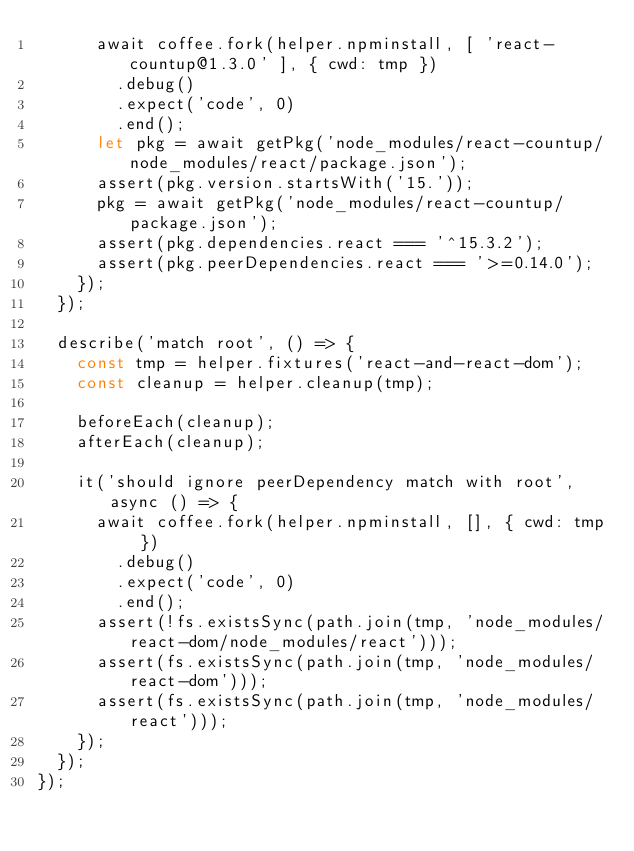Convert code to text. <code><loc_0><loc_0><loc_500><loc_500><_JavaScript_>      await coffee.fork(helper.npminstall, [ 'react-countup@1.3.0' ], { cwd: tmp })
        .debug()
        .expect('code', 0)
        .end();
      let pkg = await getPkg('node_modules/react-countup/node_modules/react/package.json');
      assert(pkg.version.startsWith('15.'));
      pkg = await getPkg('node_modules/react-countup/package.json');
      assert(pkg.dependencies.react === '^15.3.2');
      assert(pkg.peerDependencies.react === '>=0.14.0');
    });
  });

  describe('match root', () => {
    const tmp = helper.fixtures('react-and-react-dom');
    const cleanup = helper.cleanup(tmp);

    beforeEach(cleanup);
    afterEach(cleanup);

    it('should ignore peerDependency match with root', async () => {
      await coffee.fork(helper.npminstall, [], { cwd: tmp })
        .debug()
        .expect('code', 0)
        .end();
      assert(!fs.existsSync(path.join(tmp, 'node_modules/react-dom/node_modules/react')));
      assert(fs.existsSync(path.join(tmp, 'node_modules/react-dom')));
      assert(fs.existsSync(path.join(tmp, 'node_modules/react')));
    });
  });
});
</code> 